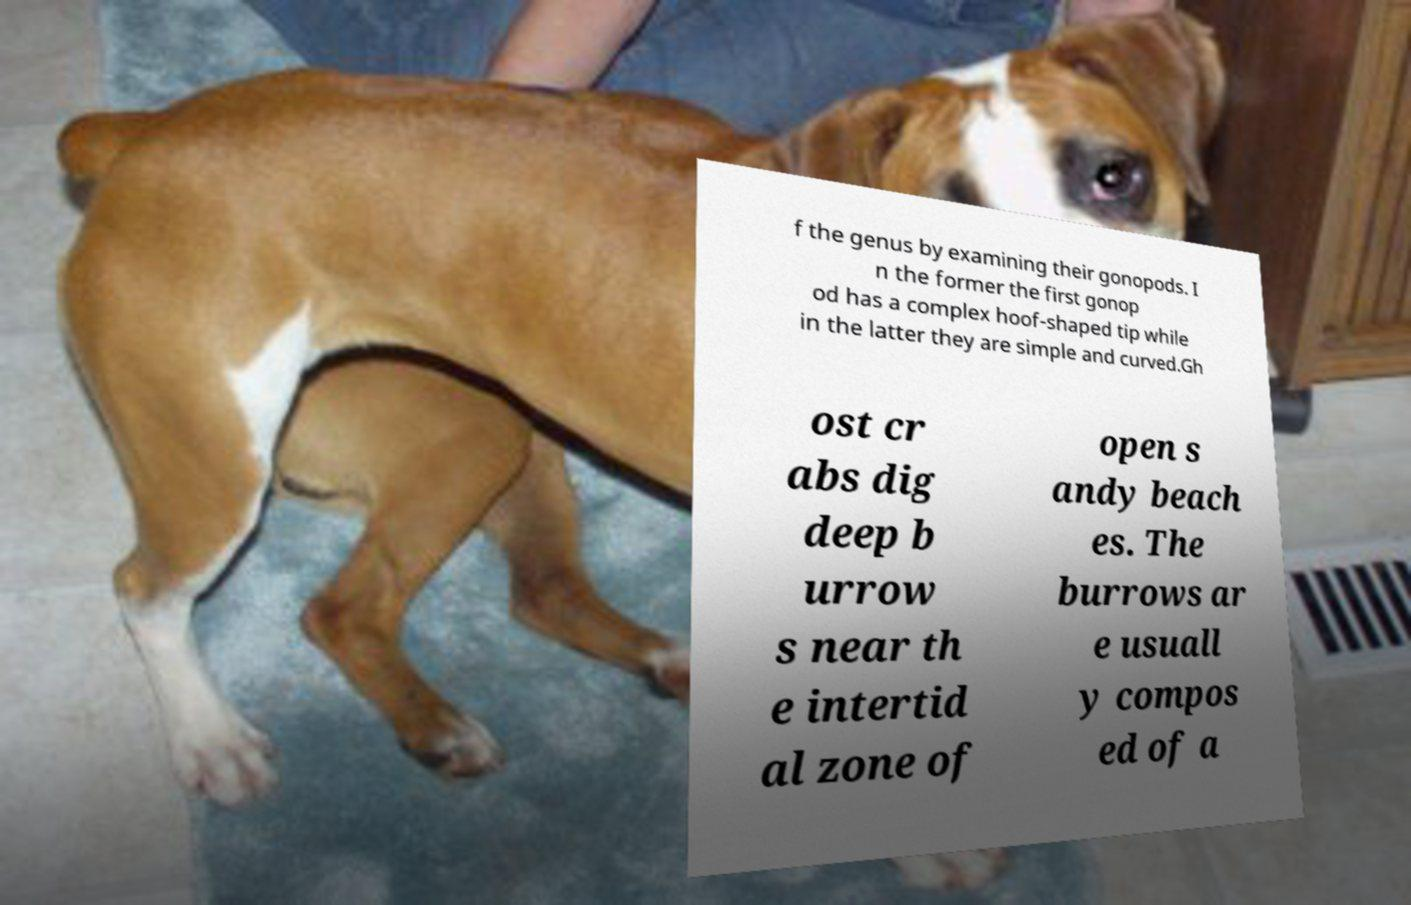Please read and relay the text visible in this image. What does it say? f the genus by examining their gonopods. I n the former the first gonop od has a complex hoof-shaped tip while in the latter they are simple and curved.Gh ost cr abs dig deep b urrow s near th e intertid al zone of open s andy beach es. The burrows ar e usuall y compos ed of a 